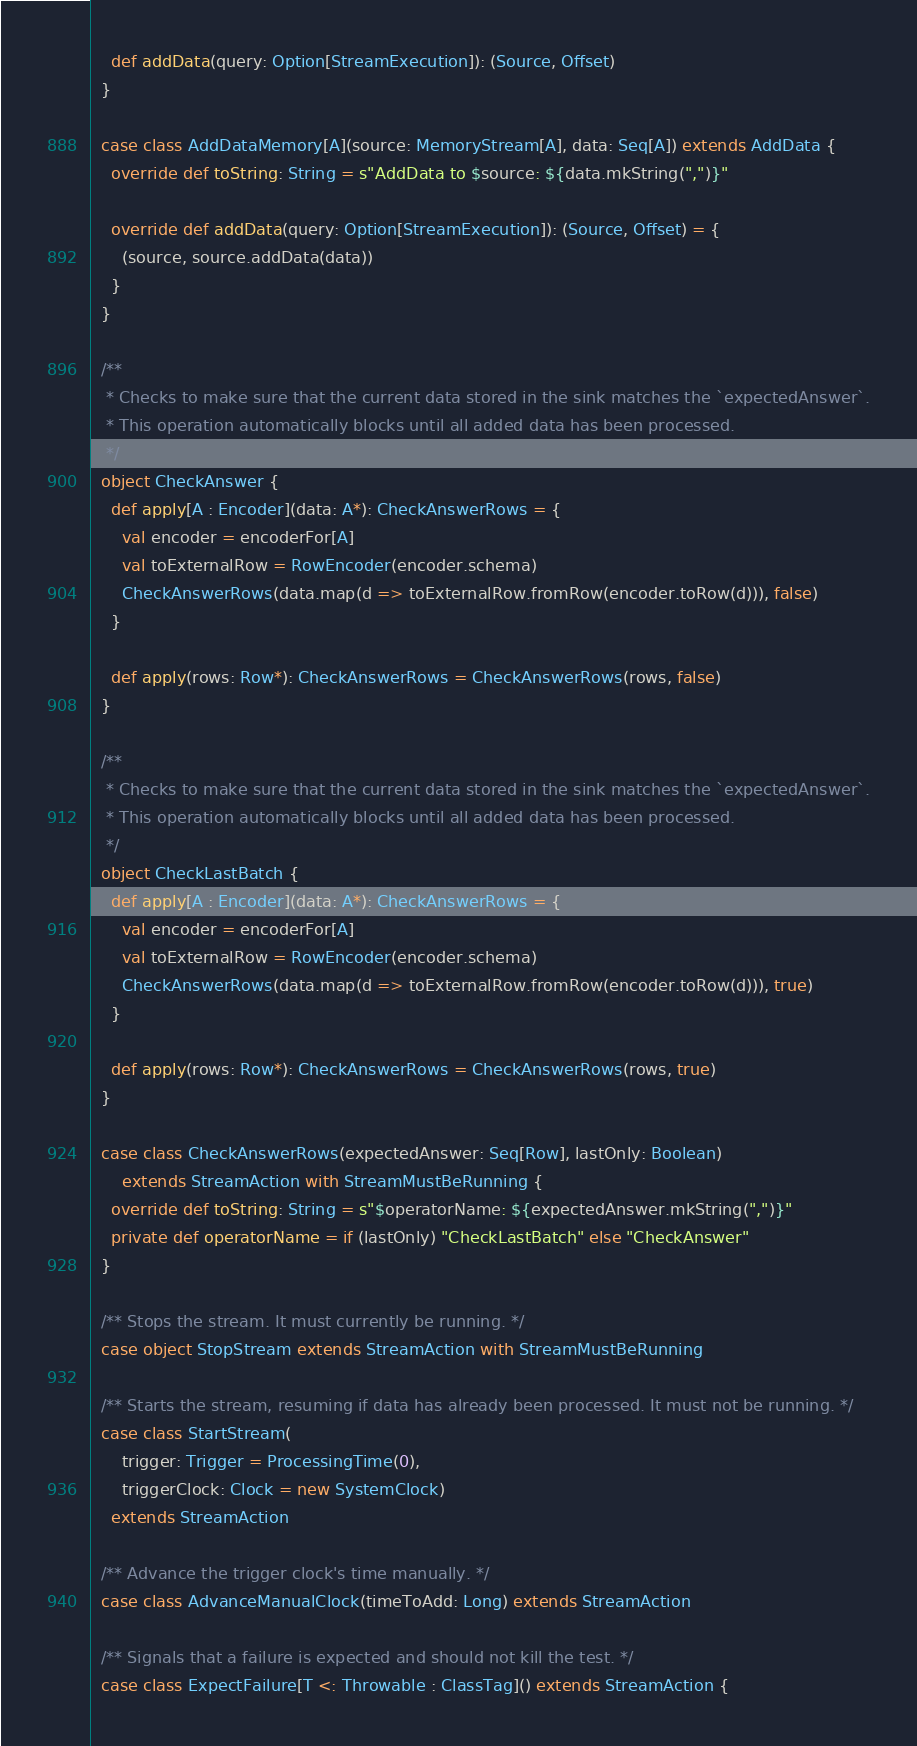Convert code to text. <code><loc_0><loc_0><loc_500><loc_500><_Scala_>    def addData(query: Option[StreamExecution]): (Source, Offset)
  }

  case class AddDataMemory[A](source: MemoryStream[A], data: Seq[A]) extends AddData {
    override def toString: String = s"AddData to $source: ${data.mkString(",")}"

    override def addData(query: Option[StreamExecution]): (Source, Offset) = {
      (source, source.addData(data))
    }
  }

  /**
   * Checks to make sure that the current data stored in the sink matches the `expectedAnswer`.
   * This operation automatically blocks until all added data has been processed.
   */
  object CheckAnswer {
    def apply[A : Encoder](data: A*): CheckAnswerRows = {
      val encoder = encoderFor[A]
      val toExternalRow = RowEncoder(encoder.schema)
      CheckAnswerRows(data.map(d => toExternalRow.fromRow(encoder.toRow(d))), false)
    }

    def apply(rows: Row*): CheckAnswerRows = CheckAnswerRows(rows, false)
  }

  /**
   * Checks to make sure that the current data stored in the sink matches the `expectedAnswer`.
   * This operation automatically blocks until all added data has been processed.
   */
  object CheckLastBatch {
    def apply[A : Encoder](data: A*): CheckAnswerRows = {
      val encoder = encoderFor[A]
      val toExternalRow = RowEncoder(encoder.schema)
      CheckAnswerRows(data.map(d => toExternalRow.fromRow(encoder.toRow(d))), true)
    }

    def apply(rows: Row*): CheckAnswerRows = CheckAnswerRows(rows, true)
  }

  case class CheckAnswerRows(expectedAnswer: Seq[Row], lastOnly: Boolean)
      extends StreamAction with StreamMustBeRunning {
    override def toString: String = s"$operatorName: ${expectedAnswer.mkString(",")}"
    private def operatorName = if (lastOnly) "CheckLastBatch" else "CheckAnswer"
  }

  /** Stops the stream. It must currently be running. */
  case object StopStream extends StreamAction with StreamMustBeRunning

  /** Starts the stream, resuming if data has already been processed. It must not be running. */
  case class StartStream(
      trigger: Trigger = ProcessingTime(0),
      triggerClock: Clock = new SystemClock)
    extends StreamAction

  /** Advance the trigger clock's time manually. */
  case class AdvanceManualClock(timeToAdd: Long) extends StreamAction

  /** Signals that a failure is expected and should not kill the test. */
  case class ExpectFailure[T <: Throwable : ClassTag]() extends StreamAction {</code> 